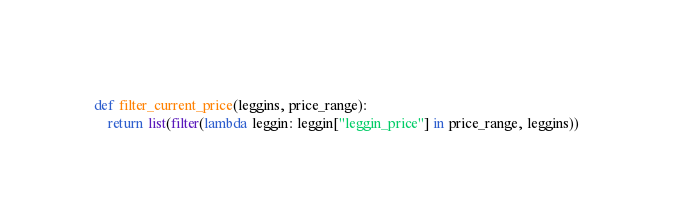Convert code to text. <code><loc_0><loc_0><loc_500><loc_500><_Python_>
def filter_current_price(leggins, price_range):
    return list(filter(lambda leggin: leggin["leggin_price"] in price_range, leggins))
</code> 